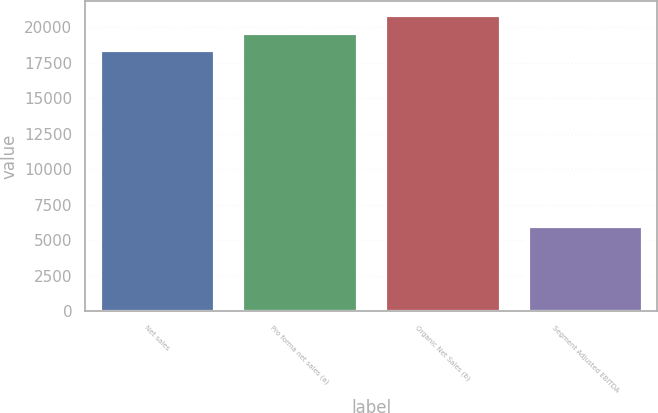<chart> <loc_0><loc_0><loc_500><loc_500><bar_chart><fcel>Net sales<fcel>Pro forma net sales (a)<fcel>Organic Net Sales (b)<fcel>Segment Adjusted EBITDA<nl><fcel>18353<fcel>19588.2<fcel>20823.4<fcel>6001<nl></chart> 